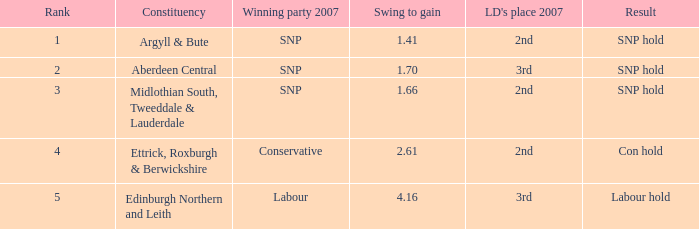16, the winning party in 2007 is snp, and ld's rank in 2007 is second? Argyll & Bute, Midlothian South, Tweeddale & Lauderdale. Would you mind parsing the complete table? {'header': ['Rank', 'Constituency', 'Winning party 2007', 'Swing to gain', "LD's place 2007", 'Result'], 'rows': [['1', 'Argyll & Bute', 'SNP', '1.41', '2nd', 'SNP hold'], ['2', 'Aberdeen Central', 'SNP', '1.70', '3rd', 'SNP hold'], ['3', 'Midlothian South, Tweeddale & Lauderdale', 'SNP', '1.66', '2nd', 'SNP hold'], ['4', 'Ettrick, Roxburgh & Berwickshire', 'Conservative', '2.61', '2nd', 'Con hold'], ['5', 'Edinburgh Northern and Leith', 'Labour', '4.16', '3rd', 'Labour hold']]} 